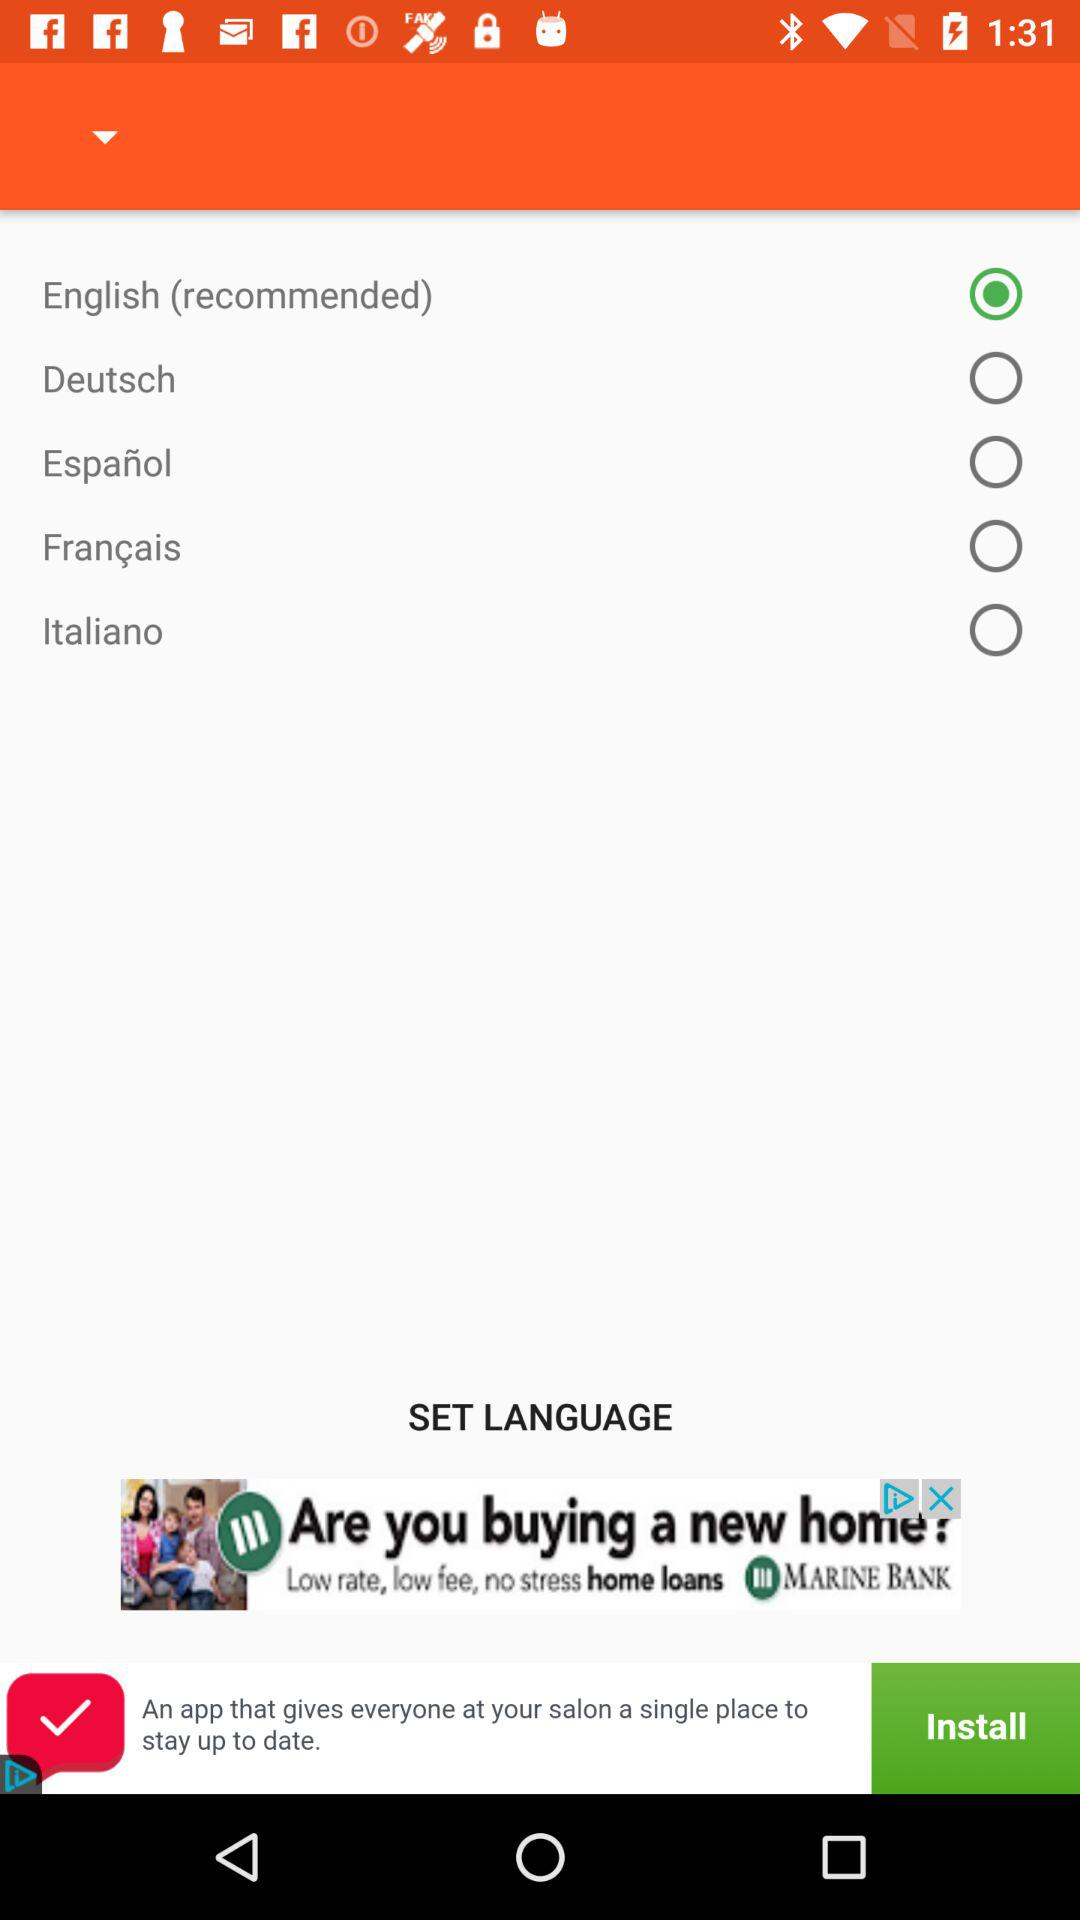How many languages are available to change to?
Answer the question using a single word or phrase. 5 